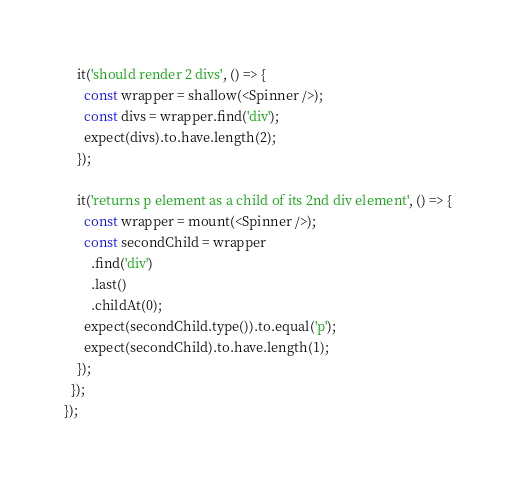Convert code to text. <code><loc_0><loc_0><loc_500><loc_500><_JavaScript_>
    it('should render 2 divs', () => {
      const wrapper = shallow(<Spinner />);
      const divs = wrapper.find('div');
      expect(divs).to.have.length(2);
    });

    it('returns p element as a child of its 2nd div element', () => {
      const wrapper = mount(<Spinner />);
      const secondChild = wrapper
        .find('div')
        .last()
        .childAt(0);
      expect(secondChild.type()).to.equal('p');
      expect(secondChild).to.have.length(1);
    });
  });
});
</code> 